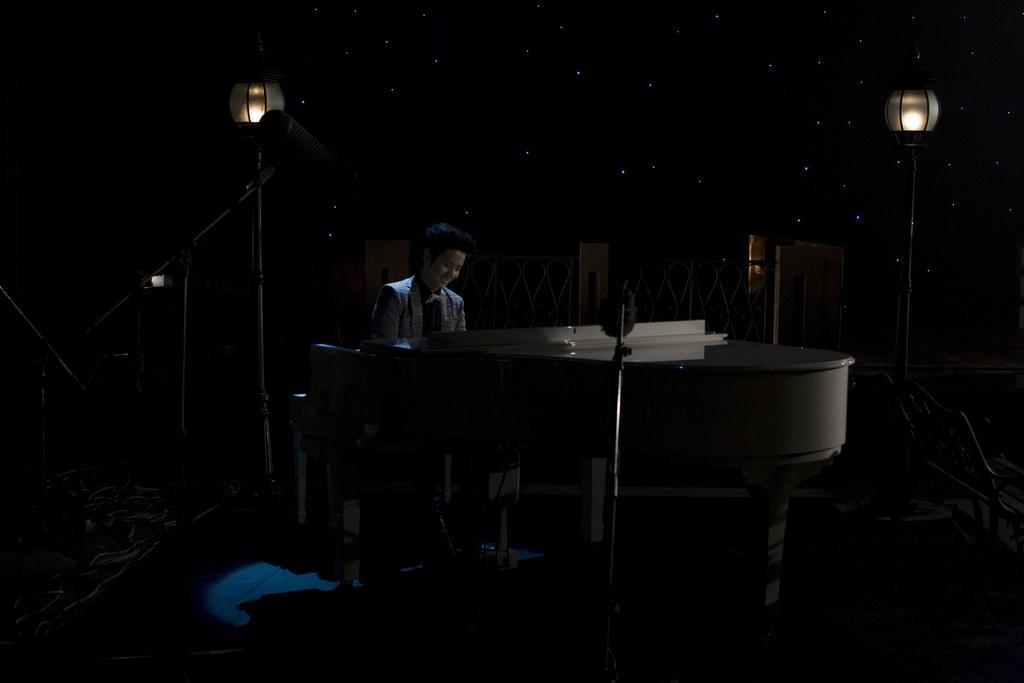Please provide a concise description of this image. In this image there is a person sitting in front of the musical instrument and smiling. In the background there is a light pole and in the front there are mice and there is a pole on the right side. There is a fence in the background. 